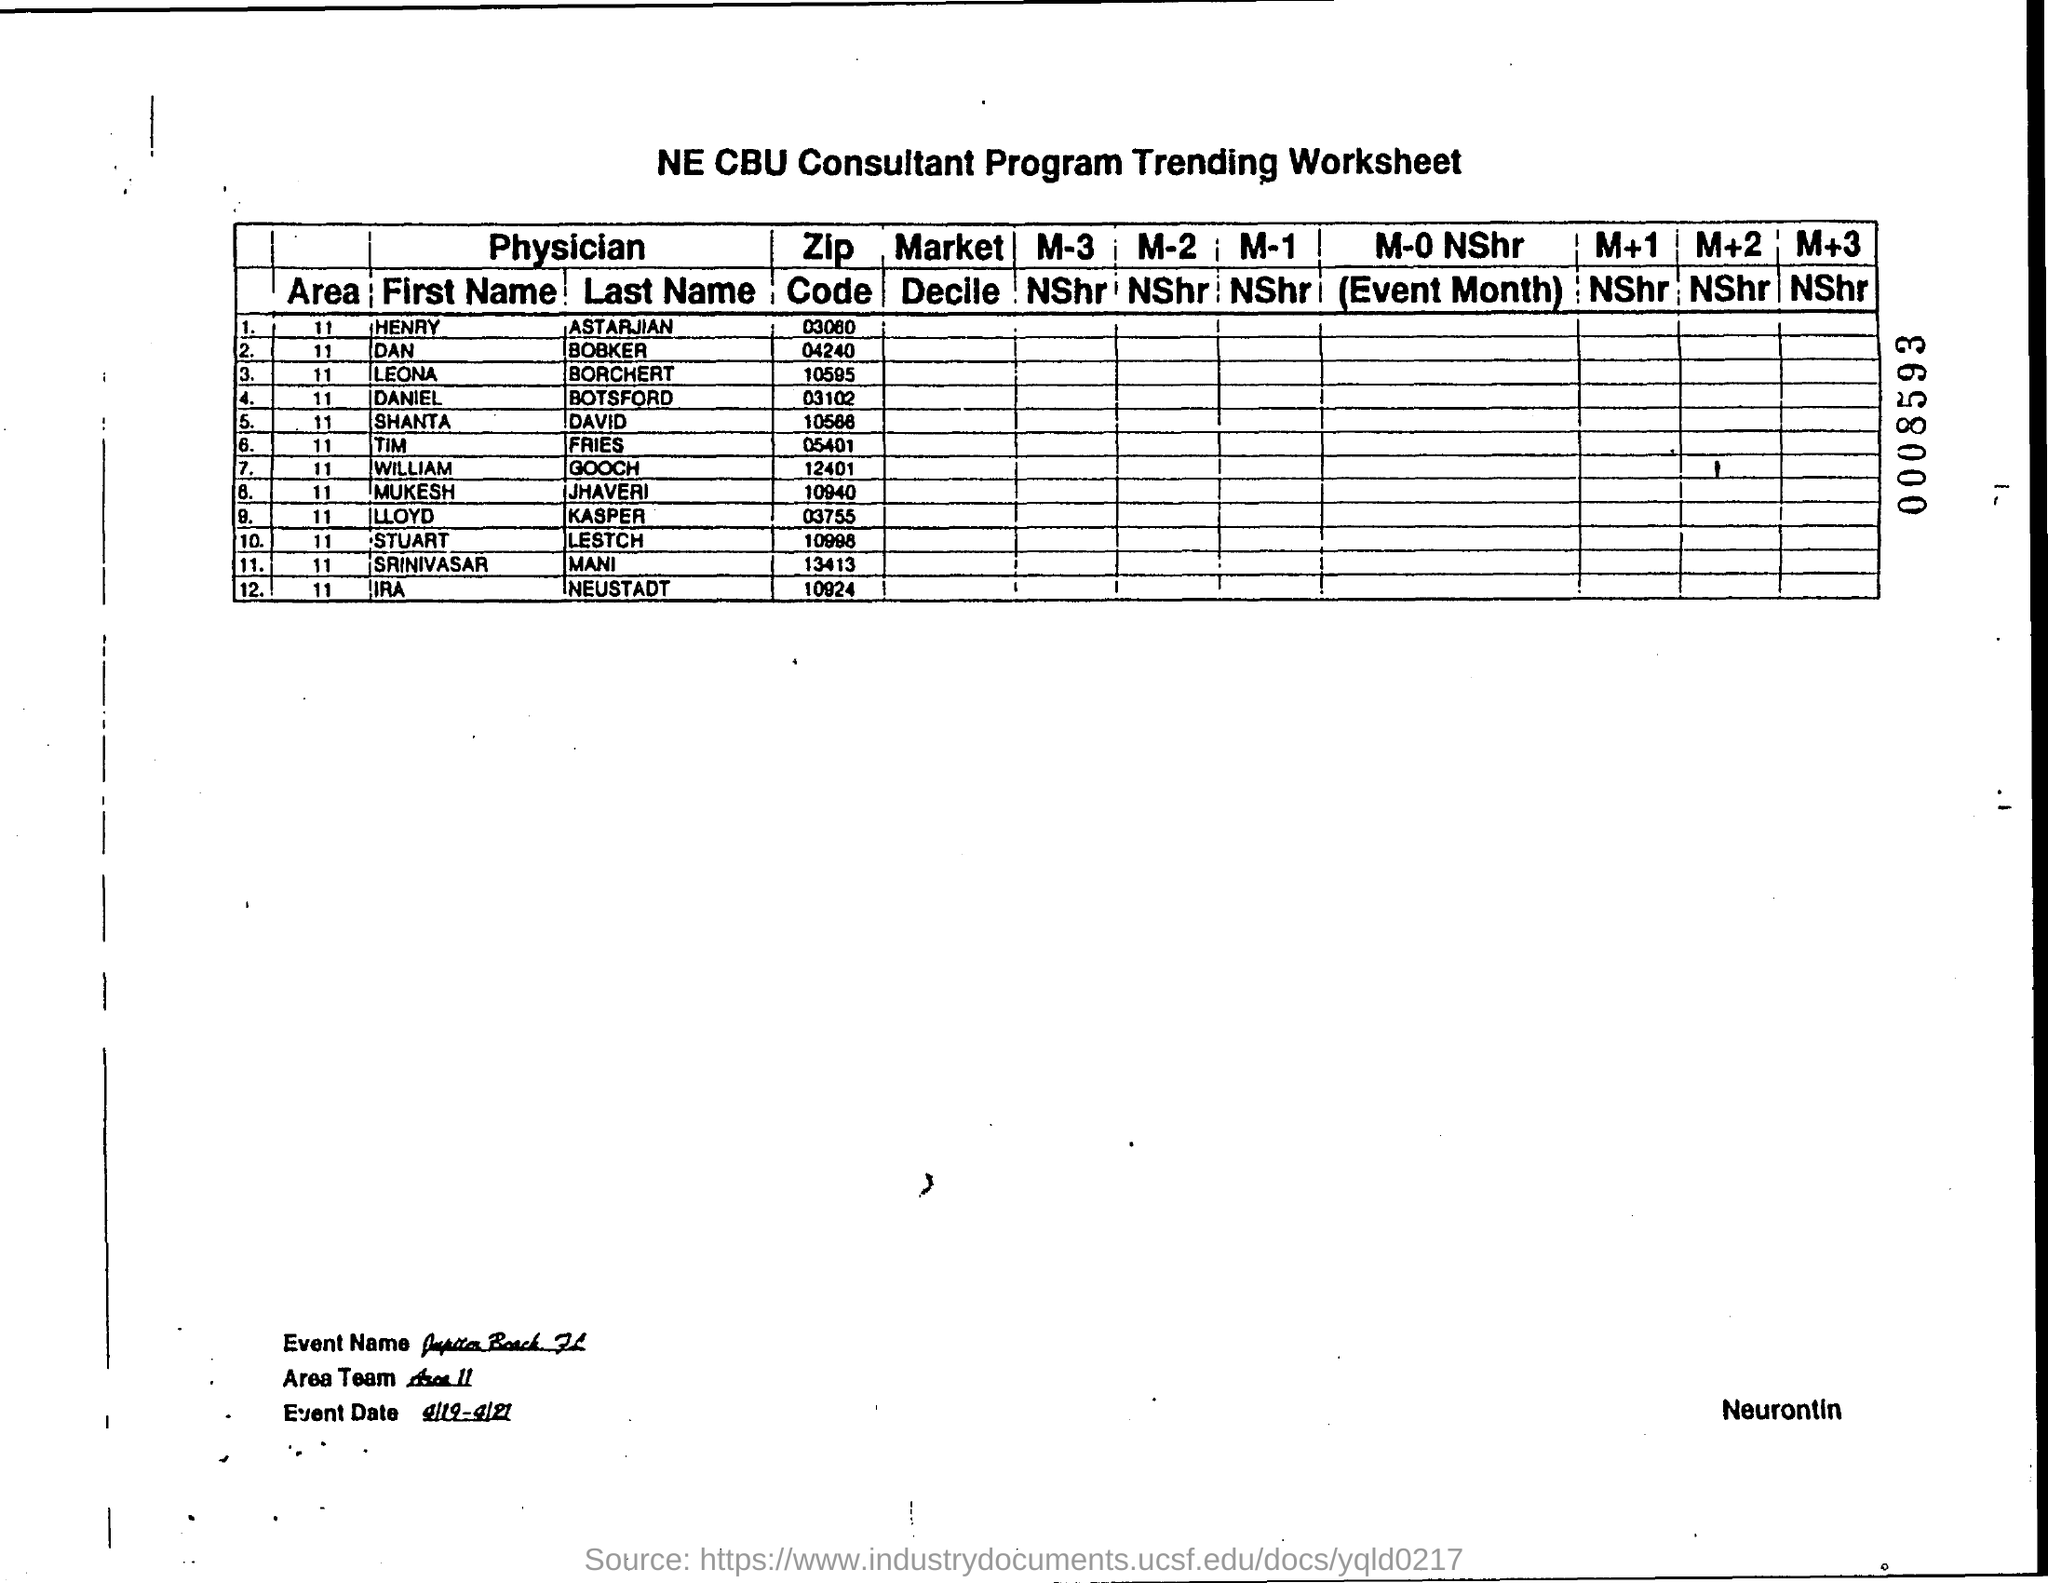Identify some key points in this picture. The zip code for William Gooch is 12401. The zip code of Daniel Botsford is 03102. Stuart Lestch's zip code is 10998. The zipcode of Leona Borchert is 10595. The zipcode of Mukesh Jhaveri is 10940. 